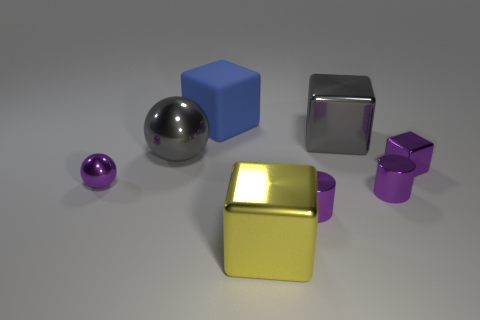What number of objects are big gray things right of the large rubber cube or big yellow metal blocks?
Ensure brevity in your answer.  2. What size is the yellow object that is made of the same material as the small purple cube?
Keep it short and to the point. Large. What number of small metallic objects have the same color as the tiny metallic ball?
Provide a short and direct response. 3. How many tiny objects are matte blocks or blue matte cylinders?
Offer a very short reply. 0. There is a object that is the same color as the large ball; what size is it?
Offer a very short reply. Large. Is there a big gray cube that has the same material as the big blue object?
Keep it short and to the point. No. There is a big blue thing that is on the right side of the purple shiny ball; what is it made of?
Give a very brief answer. Rubber. Is the color of the small object on the left side of the big blue block the same as the small thing behind the purple metal ball?
Offer a very short reply. Yes. The metallic block that is the same size as the yellow thing is what color?
Provide a succinct answer. Gray. How many other objects are there of the same shape as the big yellow object?
Make the answer very short. 3. 